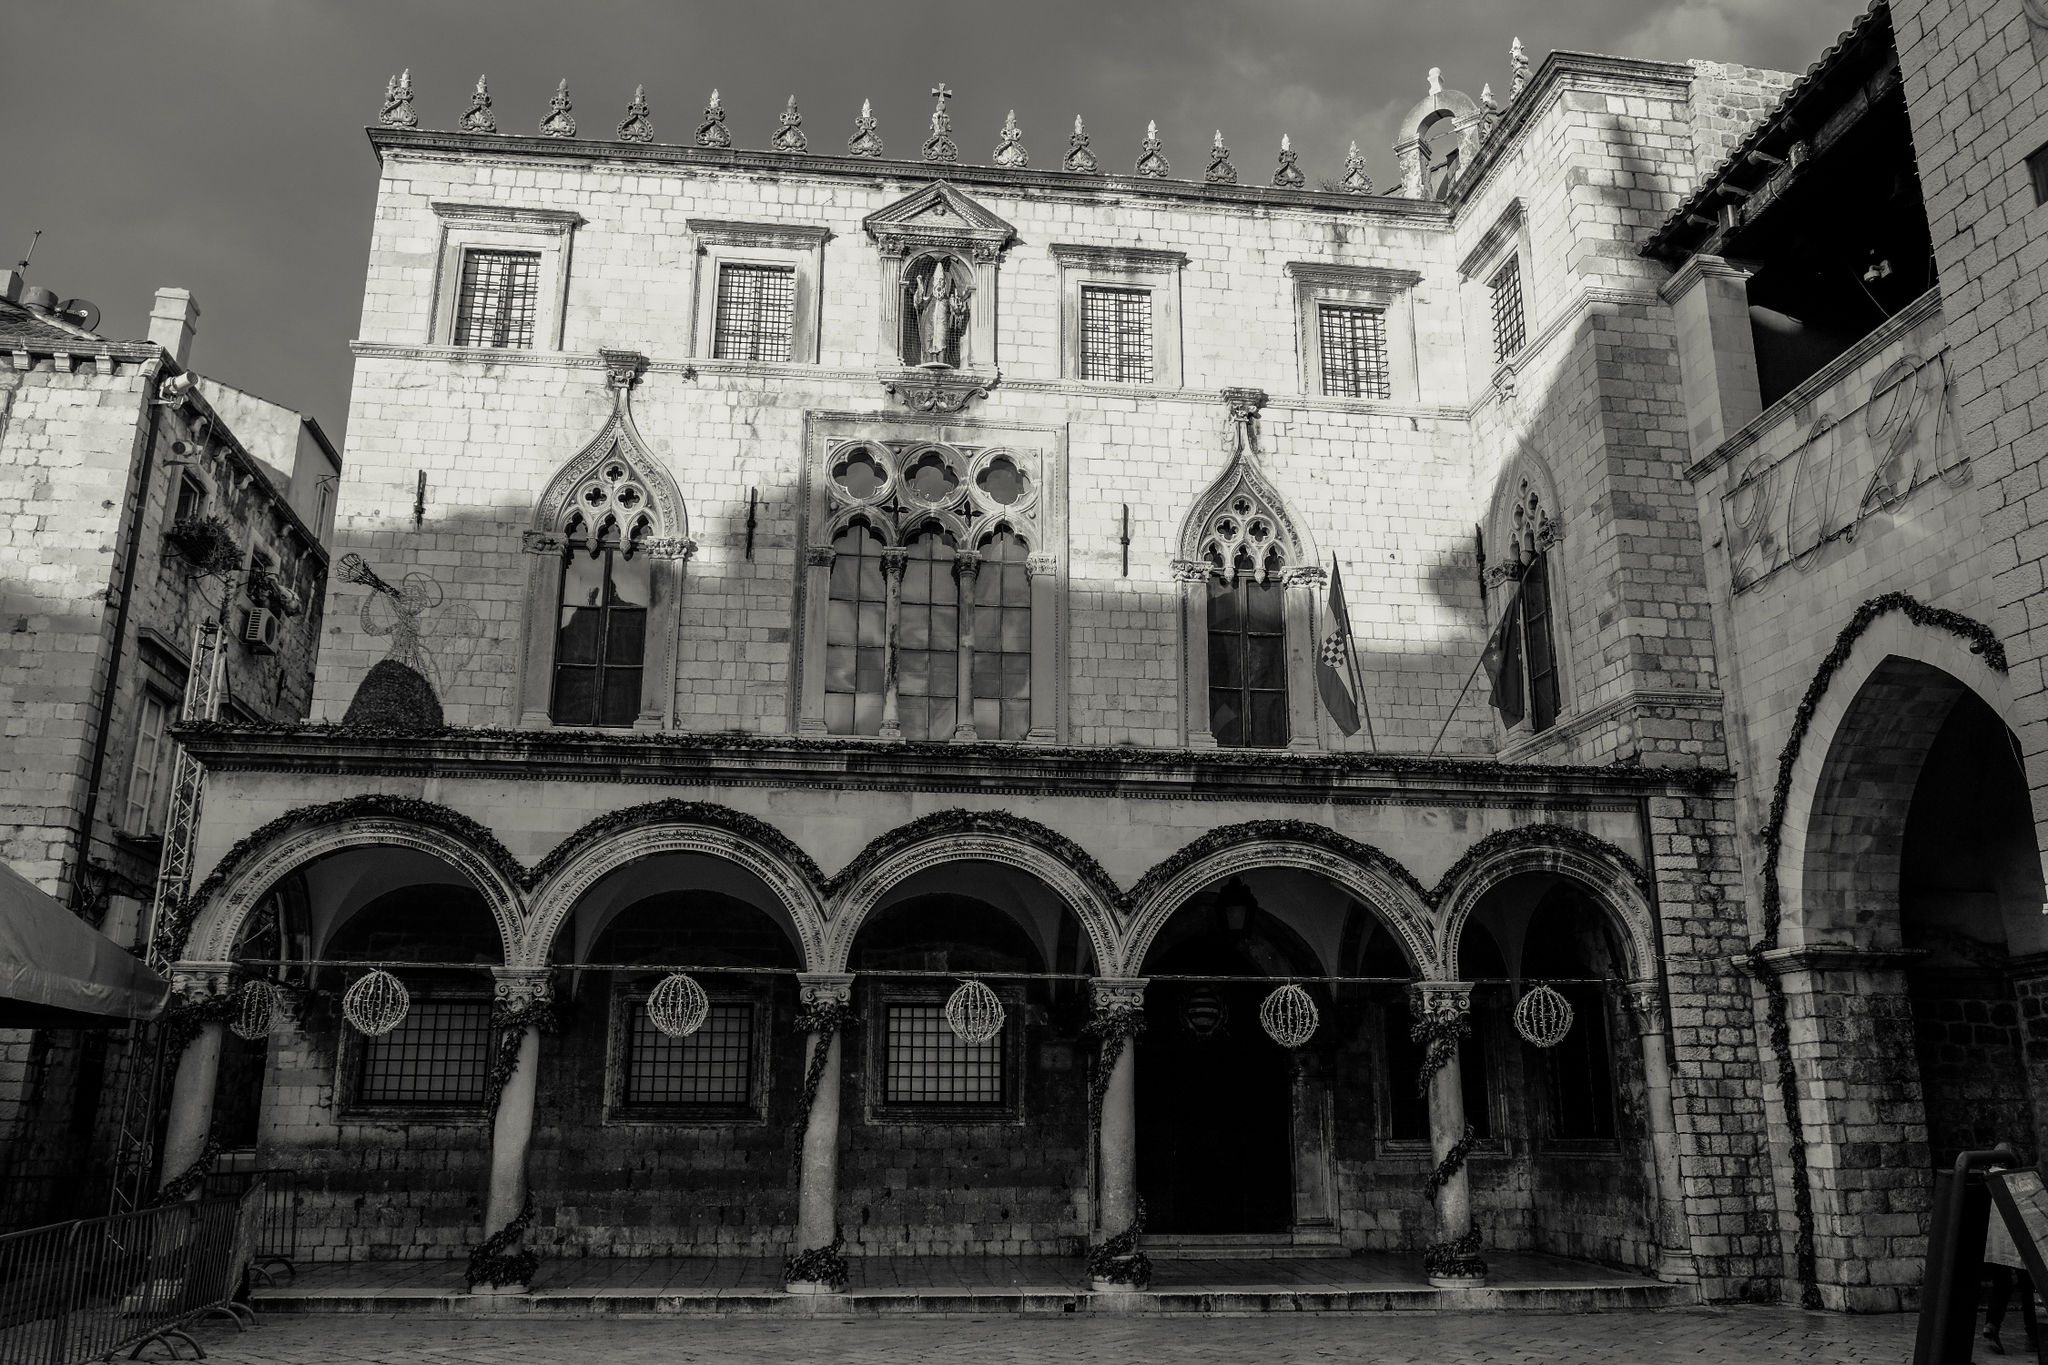What emotions does this image evoke? This image evokes a sense of awe and admiration for the historic and architectural beauty of the Rector's Palace. The majestic and solemn appearance of the building, combined with the black and white color scheme, creates a nostalgic and timeless feel. The contrast between light and shadow adds a dramatic and somewhat mysterious atmosphere, inviting contemplation about the lives and events that this structure has witnessed over the centuries. It also instills a sense of wonder about the craftsmanship and dedication that went into creating such a magnificent edifice. How do you think this building contributes to Dubrovnik's cultural identity? The Rector's Palace is a cornerstone of Dubrovnik's cultural identity. As a historical monument, it represents the city's rich past and its architectural brilliance. The palace is a reminder of Dubrovnik's status as a powerful maritime republic and a center of commerce and culture in the Adriatic region. It embodies the resilience and strength of the city through its survival of wars, earthquakes, and fires. By preserving and showcasing such a landmark, Dubrovnik fosters a sense of pride and continuity among its residents and attracts visitors from around the world, eager to connect with the city's storied heritage. 